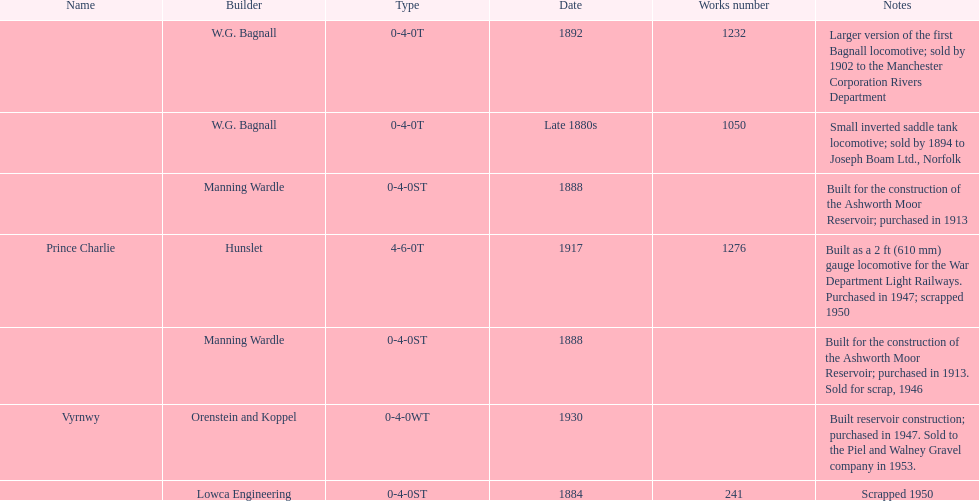How many locomotives were built after 1900? 2. 